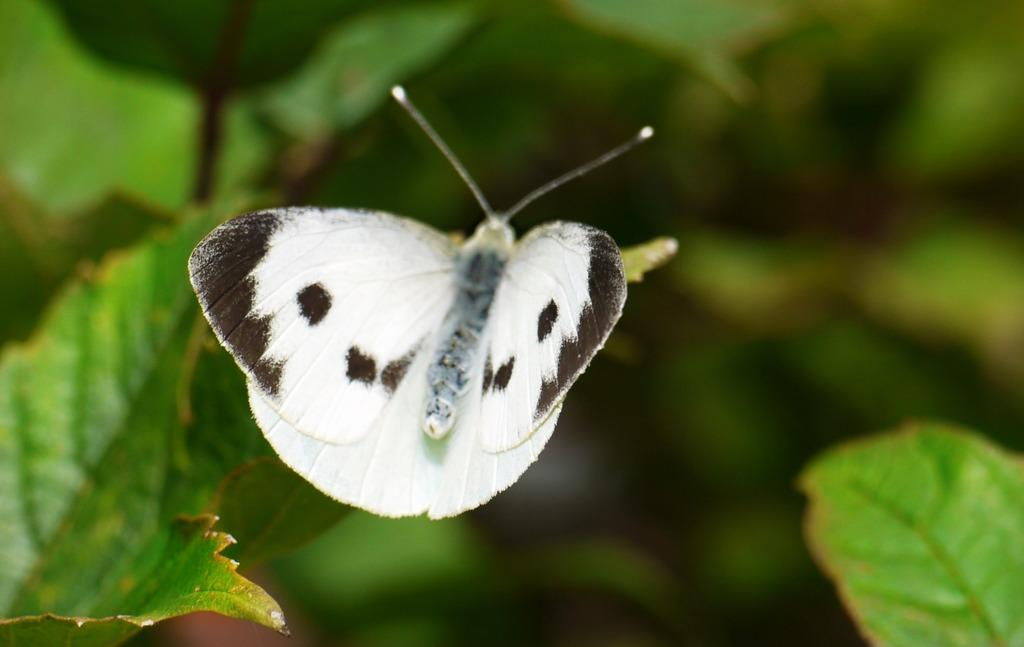What is the main subject of the picture? The main subject of the picture is a butterfly. Can you describe the color of the butterfly? The butterfly is black and white in color. What can be seen on the left side of the picture? There are leaves on the left side of the picture. What is present on the right side of the picture? There are leaves on the right side of the picture. What type of lawyer is depicted in the picture? There is no lawyer present in the picture; it features a black and white butterfly and leaves. What material is the train made of in the picture? There is no train present in the picture; it only contains a butterfly and leaves. 